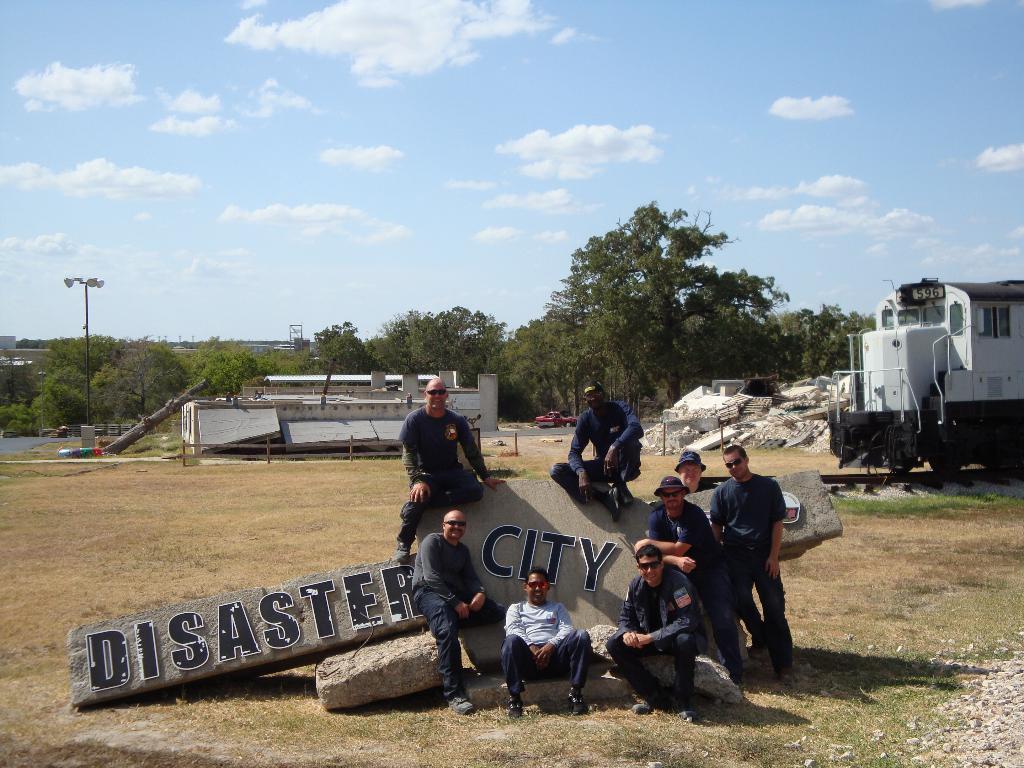In one or two sentences, can you explain what this image depicts? In this picture there are men and we can see letters on rocks, stones and grass. We can see locomotive on a railway track, shed, pole, lights, rocks, water, trees and objects. In the background of the image we can see the sky. 